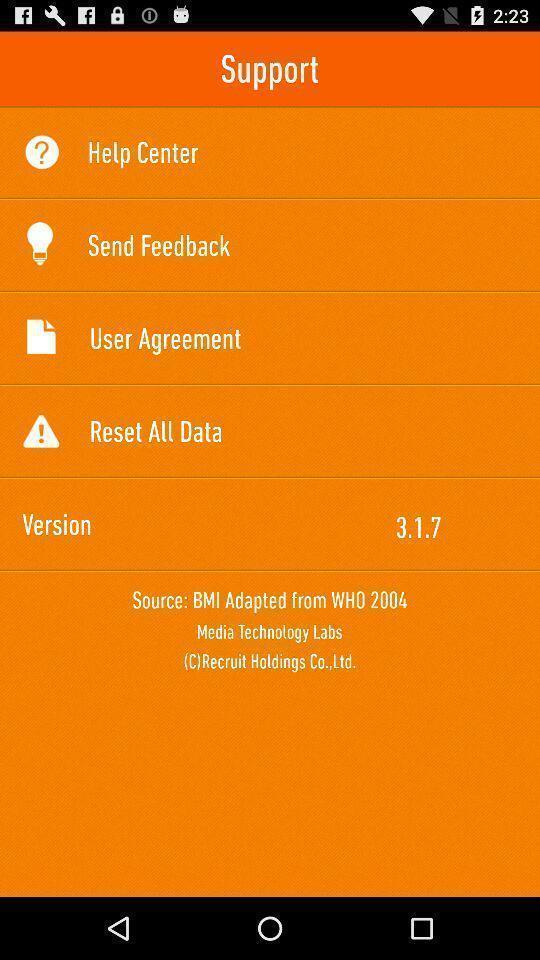Tell me what you see in this picture. Starting page with different options. 